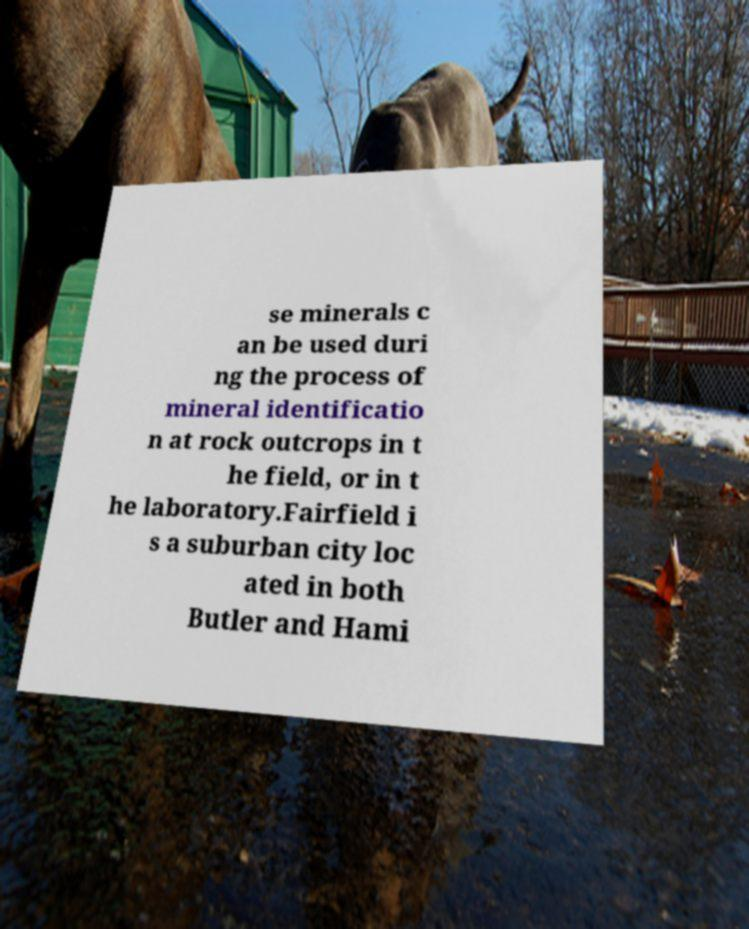I need the written content from this picture converted into text. Can you do that? se minerals c an be used duri ng the process of mineral identificatio n at rock outcrops in t he field, or in t he laboratory.Fairfield i s a suburban city loc ated in both Butler and Hami 